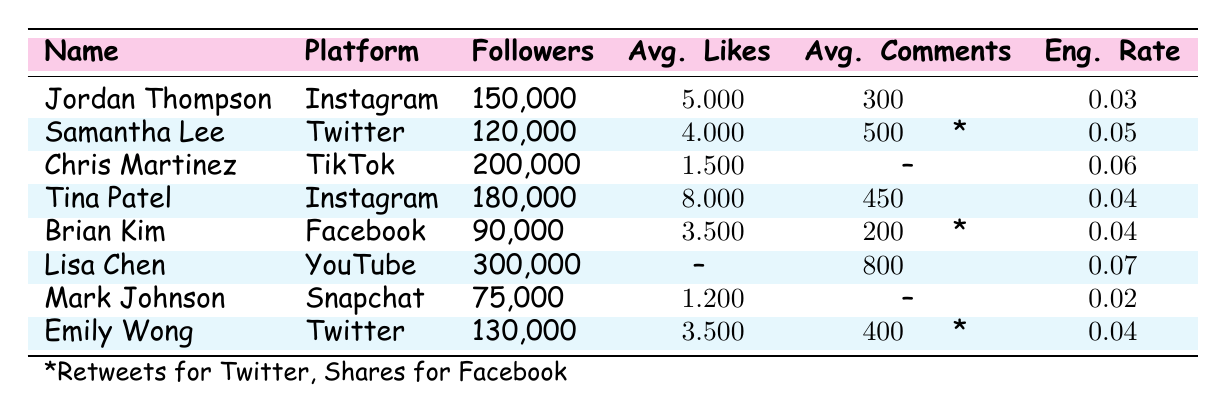What is the engagement rate for Chris Martinez? The table shows that the engagement rate for Chris Martinez, who is on TikTok, is listed directly in his row as 0.06.
Answer: 0.06 How many followers does Lisa Chen have? From the table, Lisa Chen's row states that she has 300,000 followers.
Answer: 300,000 Which cast member has the highest average likes on Instagram? By examining the rows for both Jordan Thompson and Tina Patel, Jordan has 5,000 average likes while Tina has 8,000. Thus, Tina Patel has the highest average likes on Instagram.
Answer: Tina Patel Is the engagement rate for Brian Kim greater than 0.03? The table shows that Brian Kim has an engagement rate of 0.04, which is indeed greater than 0.03.
Answer: Yes What is the total average likes for the cast members on Twitter? Samantha Lee has 4,000 average likes and Emily Wong has 3,500 average likes. Adding these values together: 4,000 + 3,500 = 7,500.
Answer: 7,500 Which platform has the highest average engagement rate? By comparing the engagement rates of all the cast members, Lisa Chen has the highest engagement rate at 0.07 on YouTube, which is higher than the others.
Answer: YouTube How does the average number of likes for cast members on Instagram compare to those on Twitter? Jordan Thompson has 5,000 average likes and Tina Patel has 8,000, making a total of 13,000. Samantha Lee has 4,000 and Emily Wong has 3,500, making a total of 7,500. Comparing these, 13,000 (Instagram total) is greater than 7,500 (Twitter total).
Answer: Instagram has more likes Is the average number of views for Snapchat above 10,000? The table shows that Mark Johnson on Snapchat has an average of 15,000 views, which is above 10,000.
Answer: Yes What is the difference in followers between Lisa Chen and Jordan Thompson? Lisa Chen has 300,000 followers and Jordan Thompson has 150,000 followers. The difference is 300,000 - 150,000 = 150,000.
Answer: 150,000 